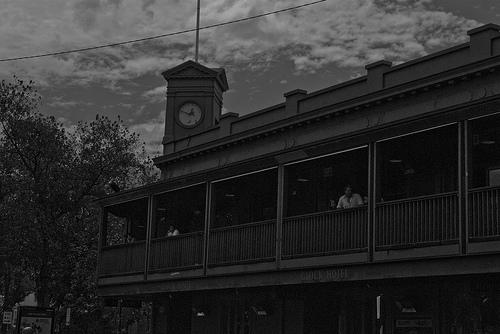Describe the presence and location of any natural elements in the photograph. There are trees next to the hotel, with one large green tree at the side of the house, and more trees off in the distance. The sky is also seen with many clouds, both blue and rain clouds. Additionally, there is an electric wire in the sky. Can you describe the building and its surrounding features? Also, mention if any advertisements or signs are visible. A wooden building with a clock tower has a balcony with wooden fence and many windows. Trees are beside the hotel, and people are on the balcony. An advertisement and a street sign are next to the road, and a large sign is on the ground. How many objects or entities are related to the clock in the image? Briefly explain each one. There are six objects related to the clock: the clock tower with the clock on the front, the round clock, the clock showing a time of 150, the words "Clock Hotel" on the building, the clock on top of the building, and a separate clock on the clock tower. What are the main architectural elements and activities taking place in the image? The image features a wooden building with a clock tower, a balcony with multiple windows, trees, and a street sign. There are people standing on the balcony and clouds in the sky. The clock tower shows a time of 150 with a round clock. What kind of weather and environment is depicted in the photograph? The photograph depicts a partly cloudy day with many clouds in the sky and trees surrounding the hotel. The environment is likely an urban setting with a mix of nature and architecture. Provide a detailed description of the clock tower and its surrounding context. The clock tower has a round clock on the front displaying a time of 150. It is part of a wooden building that has a balcony with wooden fence and multiple windows. There are also trees next to the hotel, people on the balcony and an electric wire hanging over the building. How many people can be seen in the image, and what are some of their notable activities? There are multiple people in the image, but no specific number is given. They are mainly standing on the balcony, leaning against the railing or watching something over the wooden porch. What is the color scheme of the image and the main objects in it? The photograph is brown in color, featuring a wooden building, a clock tower, trees, people on a balcony, clouds and signs, all of which also have different shades of brown color. What are the people doing in the image and their attire? People are standing on the balcony, looking over the railing, possibly watching something. One man is wearing a long sleeve white shirt and leaning against the railing. Do you notice the hot air balloon floating high above the clock tower? The colorful stripes on the balloon contrast beautifully with the cloudy sky. Have you seen the golden statue of a lion on top of the clock tower? The majestic lion statue symbolizes the regal nature of the hotel. Can you spot the unicorn grazing in the grass beside the hotel? There is a beautiful, multicolored unicorn just by the trees. Can you see the vintage car parked by the side of the hotel, right next to the trees? The bright red car with its shiny chrome accents stands out among the surrounding objects. Find the elderly woman who is knitting a scarf outside the front door of the clock hotel. You'll notice her rocking chair and the vibrant yellow scarf she's crafting. Is there a storefront with a bright red awning to the left of the hotel? I can see a bustling café inviting people in with the aroma of coffee and baked goods. 